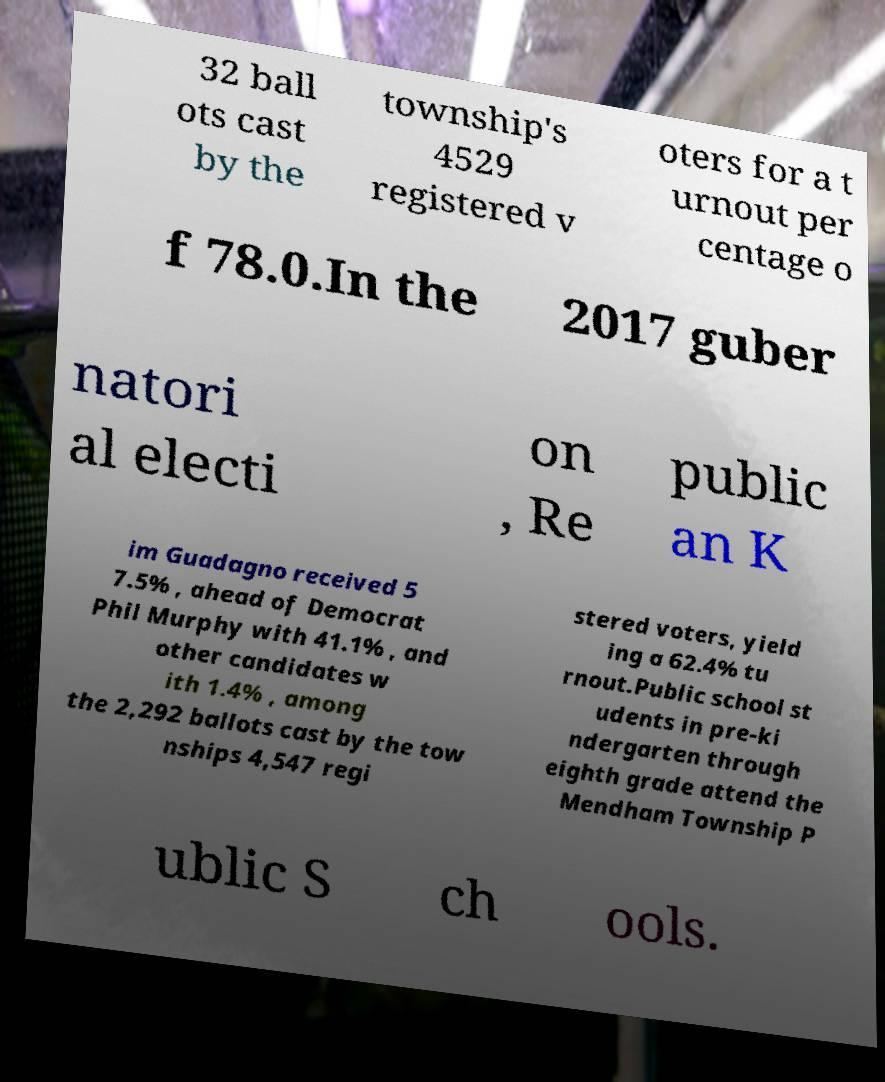Can you read and provide the text displayed in the image?This photo seems to have some interesting text. Can you extract and type it out for me? 32 ball ots cast by the township's 4529 registered v oters for a t urnout per centage o f 78.0.In the 2017 guber natori al electi on , Re public an K im Guadagno received 5 7.5% , ahead of Democrat Phil Murphy with 41.1% , and other candidates w ith 1.4% , among the 2,292 ballots cast by the tow nships 4,547 regi stered voters, yield ing a 62.4% tu rnout.Public school st udents in pre-ki ndergarten through eighth grade attend the Mendham Township P ublic S ch ools. 